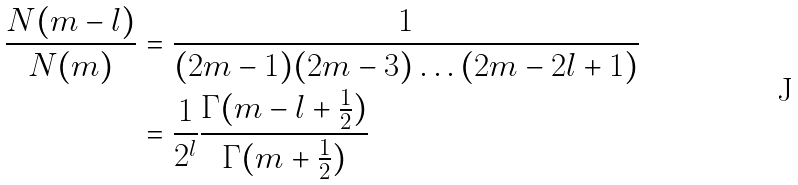Convert formula to latex. <formula><loc_0><loc_0><loc_500><loc_500>\frac { N ( m - l ) } { N ( m ) } & = \frac { 1 } { ( 2 m - 1 ) ( 2 m - 3 ) \dots ( 2 m - 2 l + 1 ) } \\ & = \frac { 1 } { 2 ^ { l } } \frac { \Gamma ( m - l + \frac { 1 } { 2 } ) } { \Gamma ( m + \frac { 1 } { 2 } ) } \\</formula> 